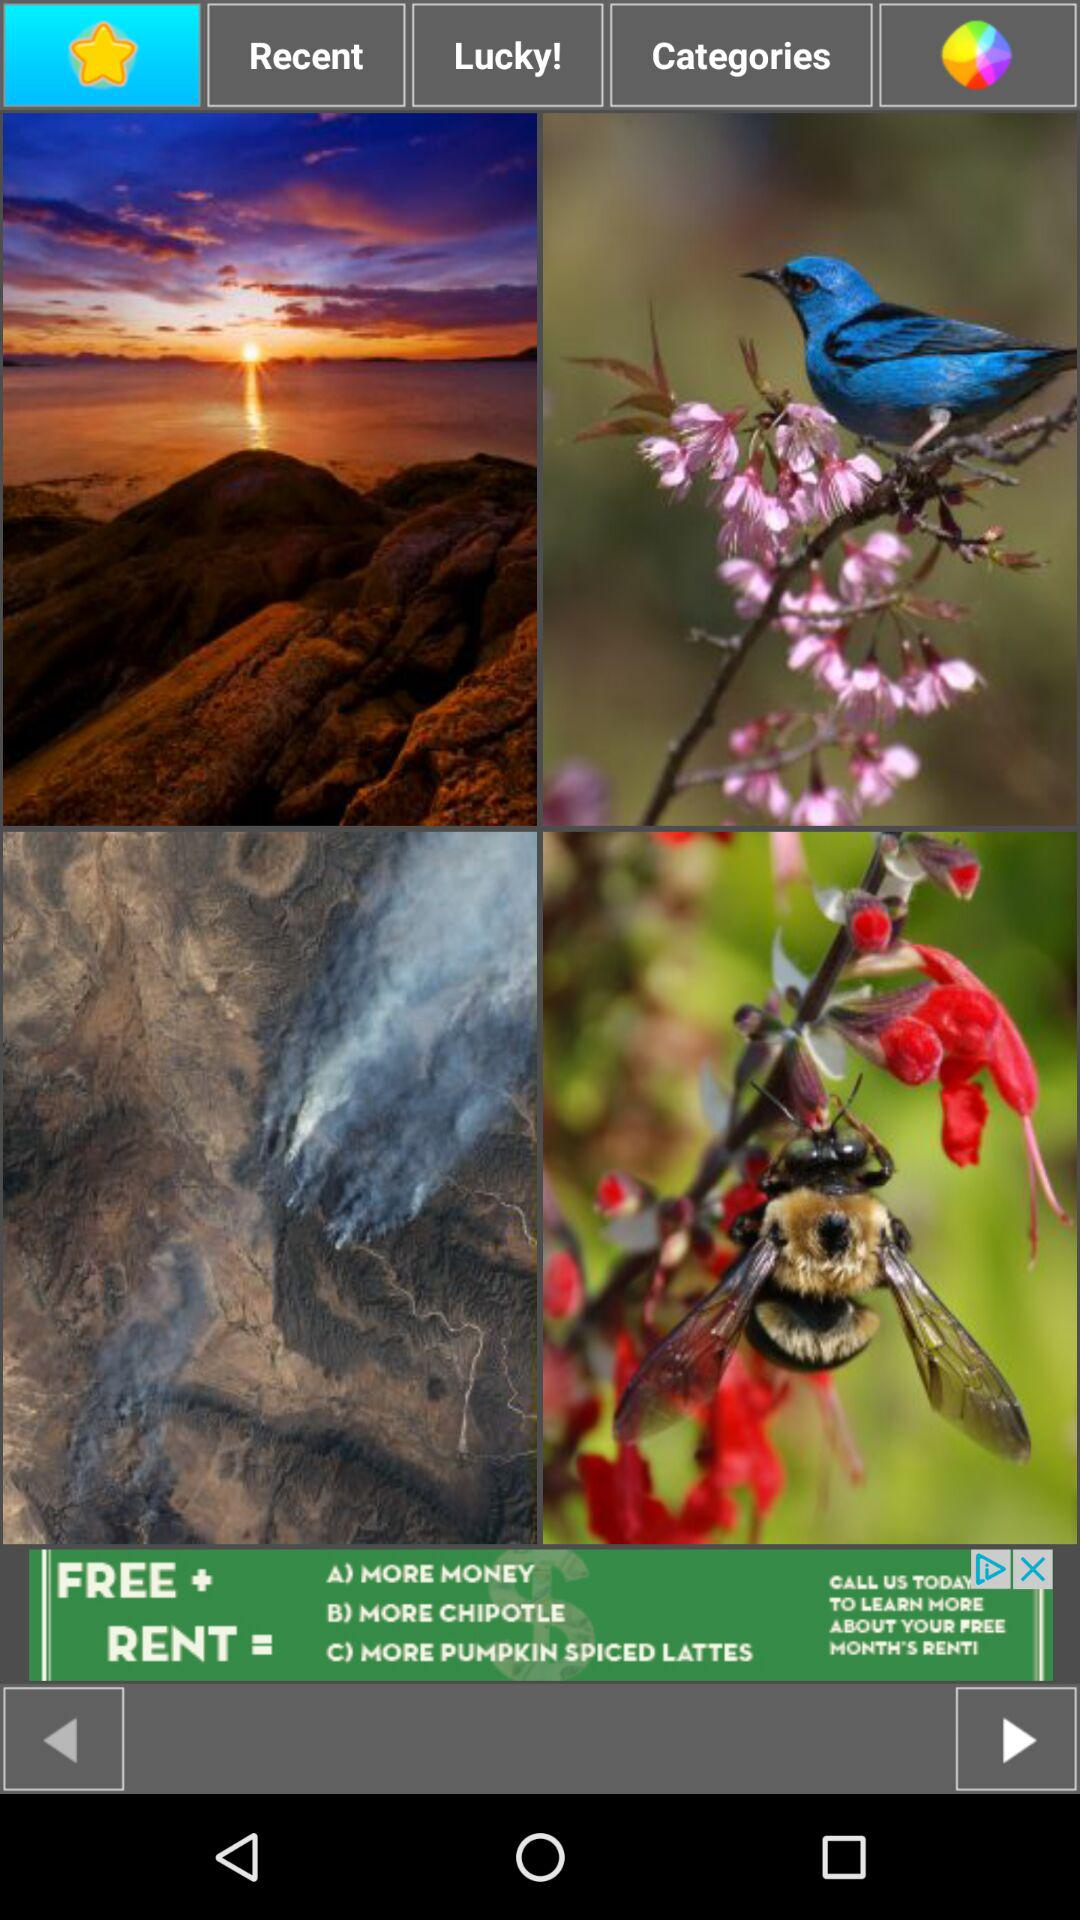Which tab is selected?
When the provided information is insufficient, respond with <no answer>. <no answer> 